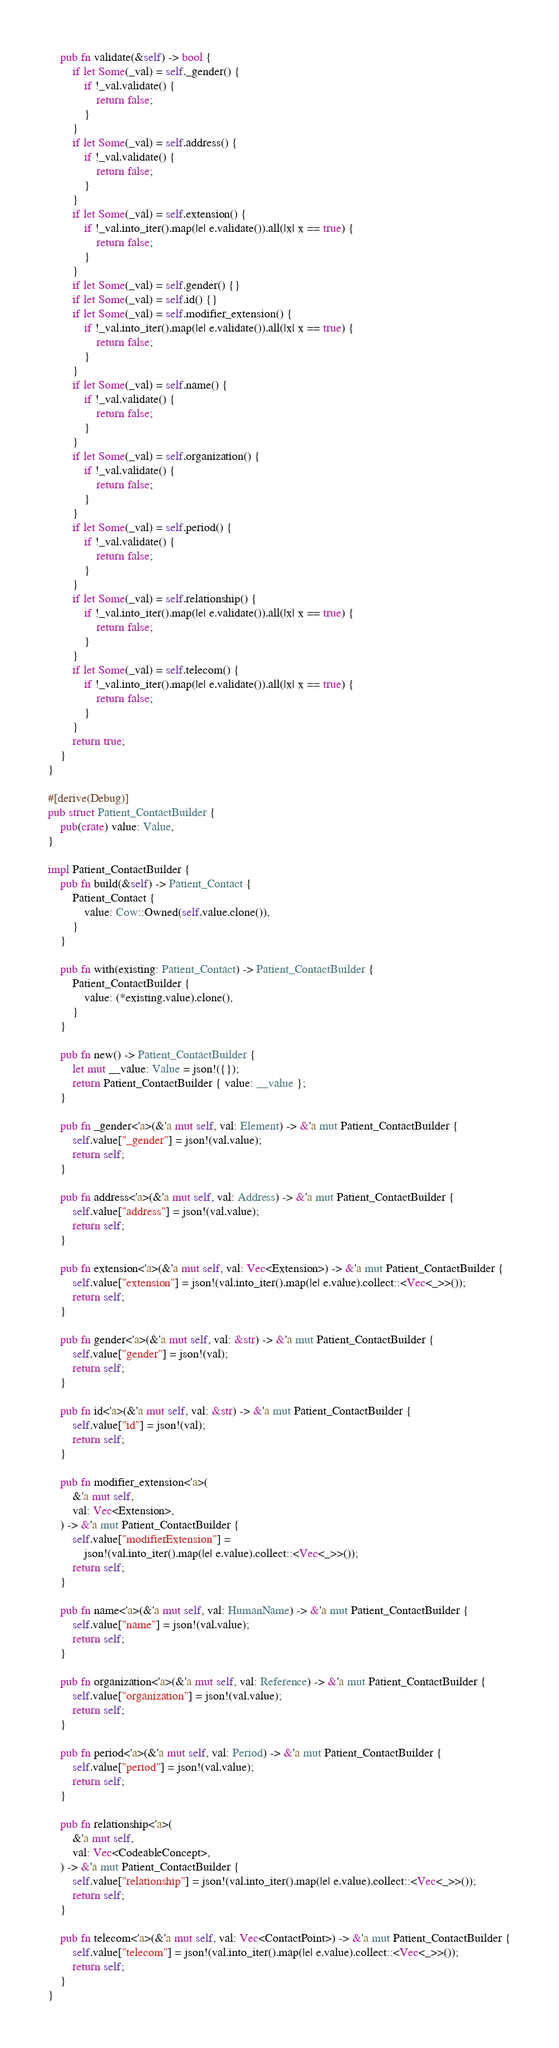<code> <loc_0><loc_0><loc_500><loc_500><_Rust_>    pub fn validate(&self) -> bool {
        if let Some(_val) = self._gender() {
            if !_val.validate() {
                return false;
            }
        }
        if let Some(_val) = self.address() {
            if !_val.validate() {
                return false;
            }
        }
        if let Some(_val) = self.extension() {
            if !_val.into_iter().map(|e| e.validate()).all(|x| x == true) {
                return false;
            }
        }
        if let Some(_val) = self.gender() {}
        if let Some(_val) = self.id() {}
        if let Some(_val) = self.modifier_extension() {
            if !_val.into_iter().map(|e| e.validate()).all(|x| x == true) {
                return false;
            }
        }
        if let Some(_val) = self.name() {
            if !_val.validate() {
                return false;
            }
        }
        if let Some(_val) = self.organization() {
            if !_val.validate() {
                return false;
            }
        }
        if let Some(_val) = self.period() {
            if !_val.validate() {
                return false;
            }
        }
        if let Some(_val) = self.relationship() {
            if !_val.into_iter().map(|e| e.validate()).all(|x| x == true) {
                return false;
            }
        }
        if let Some(_val) = self.telecom() {
            if !_val.into_iter().map(|e| e.validate()).all(|x| x == true) {
                return false;
            }
        }
        return true;
    }
}

#[derive(Debug)]
pub struct Patient_ContactBuilder {
    pub(crate) value: Value,
}

impl Patient_ContactBuilder {
    pub fn build(&self) -> Patient_Contact {
        Patient_Contact {
            value: Cow::Owned(self.value.clone()),
        }
    }

    pub fn with(existing: Patient_Contact) -> Patient_ContactBuilder {
        Patient_ContactBuilder {
            value: (*existing.value).clone(),
        }
    }

    pub fn new() -> Patient_ContactBuilder {
        let mut __value: Value = json!({});
        return Patient_ContactBuilder { value: __value };
    }

    pub fn _gender<'a>(&'a mut self, val: Element) -> &'a mut Patient_ContactBuilder {
        self.value["_gender"] = json!(val.value);
        return self;
    }

    pub fn address<'a>(&'a mut self, val: Address) -> &'a mut Patient_ContactBuilder {
        self.value["address"] = json!(val.value);
        return self;
    }

    pub fn extension<'a>(&'a mut self, val: Vec<Extension>) -> &'a mut Patient_ContactBuilder {
        self.value["extension"] = json!(val.into_iter().map(|e| e.value).collect::<Vec<_>>());
        return self;
    }

    pub fn gender<'a>(&'a mut self, val: &str) -> &'a mut Patient_ContactBuilder {
        self.value["gender"] = json!(val);
        return self;
    }

    pub fn id<'a>(&'a mut self, val: &str) -> &'a mut Patient_ContactBuilder {
        self.value["id"] = json!(val);
        return self;
    }

    pub fn modifier_extension<'a>(
        &'a mut self,
        val: Vec<Extension>,
    ) -> &'a mut Patient_ContactBuilder {
        self.value["modifierExtension"] =
            json!(val.into_iter().map(|e| e.value).collect::<Vec<_>>());
        return self;
    }

    pub fn name<'a>(&'a mut self, val: HumanName) -> &'a mut Patient_ContactBuilder {
        self.value["name"] = json!(val.value);
        return self;
    }

    pub fn organization<'a>(&'a mut self, val: Reference) -> &'a mut Patient_ContactBuilder {
        self.value["organization"] = json!(val.value);
        return self;
    }

    pub fn period<'a>(&'a mut self, val: Period) -> &'a mut Patient_ContactBuilder {
        self.value["period"] = json!(val.value);
        return self;
    }

    pub fn relationship<'a>(
        &'a mut self,
        val: Vec<CodeableConcept>,
    ) -> &'a mut Patient_ContactBuilder {
        self.value["relationship"] = json!(val.into_iter().map(|e| e.value).collect::<Vec<_>>());
        return self;
    }

    pub fn telecom<'a>(&'a mut self, val: Vec<ContactPoint>) -> &'a mut Patient_ContactBuilder {
        self.value["telecom"] = json!(val.into_iter().map(|e| e.value).collect::<Vec<_>>());
        return self;
    }
}
</code> 